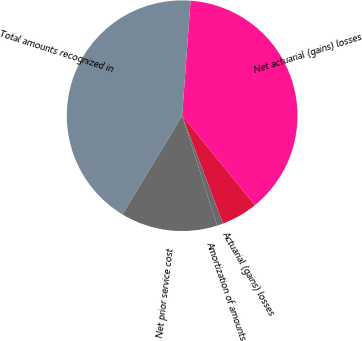Convert chart. <chart><loc_0><loc_0><loc_500><loc_500><pie_chart><fcel>Net actuarial (gains) losses<fcel>Actuarial (gains) losses<fcel>Amortization of amounts<fcel>Net prior service cost<fcel>Total amounts recognized in<nl><fcel>37.97%<fcel>5.1%<fcel>0.86%<fcel>13.57%<fcel>42.5%<nl></chart> 